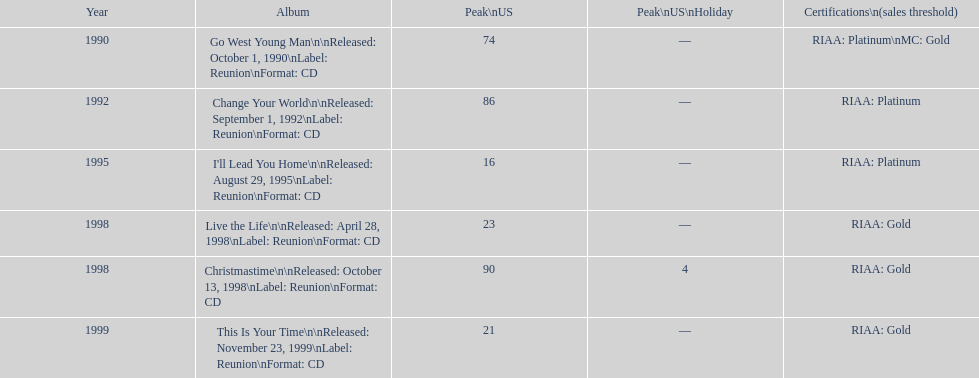The oldest year listed is what? 1990. Parse the table in full. {'header': ['Year', 'Album', 'Peak\\nUS', 'Peak\\nUS\\nHoliday', 'Certifications\\n(sales threshold)'], 'rows': [['1990', 'Go West Young Man\\n\\nReleased: October 1, 1990\\nLabel: Reunion\\nFormat: CD', '74', '—', 'RIAA: Platinum\\nMC: Gold'], ['1992', 'Change Your World\\n\\nReleased: September 1, 1992\\nLabel: Reunion\\nFormat: CD', '86', '—', 'RIAA: Platinum'], ['1995', "I'll Lead You Home\\n\\nReleased: August 29, 1995\\nLabel: Reunion\\nFormat: CD", '16', '—', 'RIAA: Platinum'], ['1998', 'Live the Life\\n\\nReleased: April 28, 1998\\nLabel: Reunion\\nFormat: CD', '23', '—', 'RIAA: Gold'], ['1998', 'Christmastime\\n\\nReleased: October 13, 1998\\nLabel: Reunion\\nFormat: CD', '90', '4', 'RIAA: Gold'], ['1999', 'This Is Your Time\\n\\nReleased: November 23, 1999\\nLabel: Reunion\\nFormat: CD', '21', '—', 'RIAA: Gold']]} 